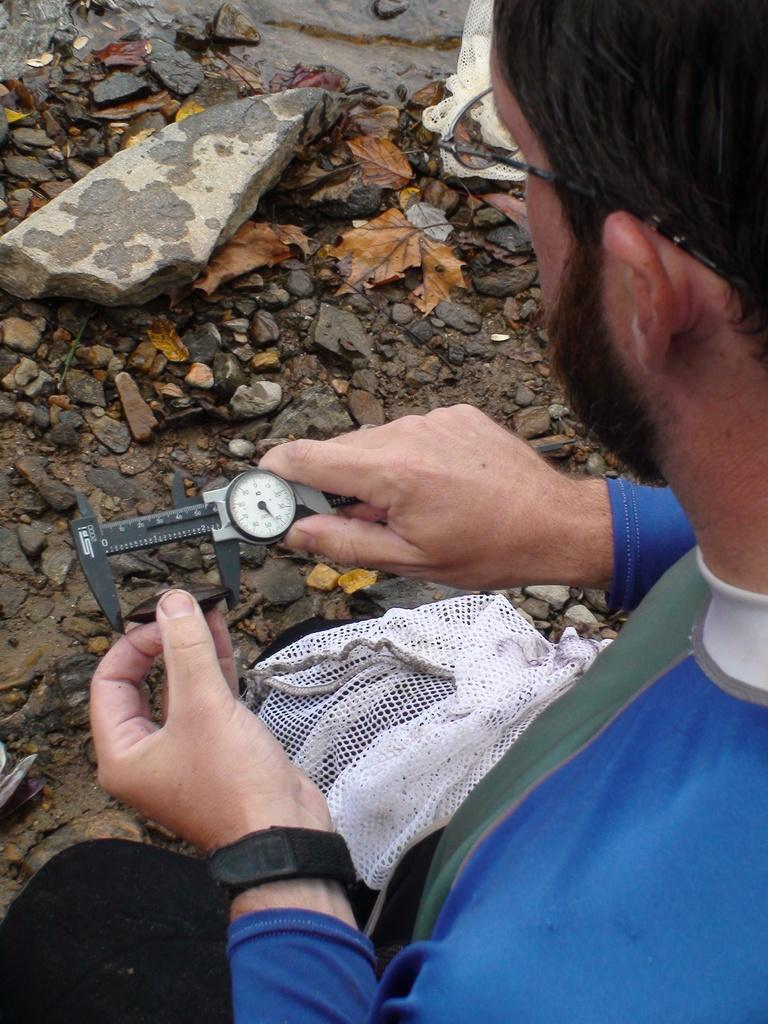What can be seen in the image? There is a person in the image. Can you describe the person's attire? The person is wearing a blue dress and spectacles. What is the person holding in his hand? The person is holding a device in his hand. What can be seen in the background of the image? There is a group of stones and a bag in the background of the image. What type of floor can be seen in the image? There is no floor visible in the image; it appears to be an outdoor setting. What position is the person in the image? The person's position cannot be determined from the image, as it only shows a frontal view. 